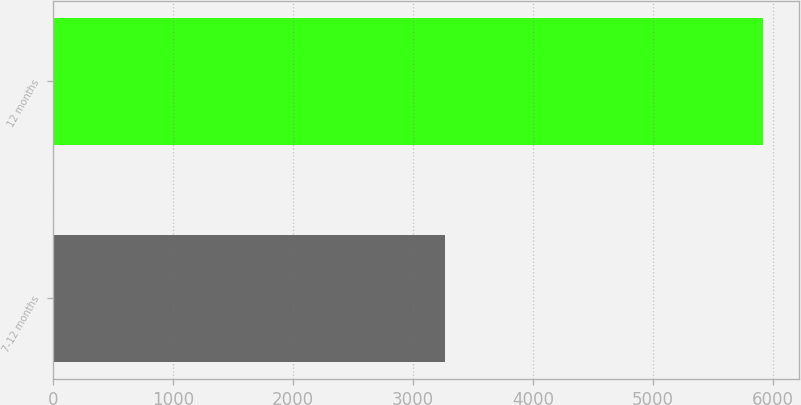<chart> <loc_0><loc_0><loc_500><loc_500><bar_chart><fcel>7-12 months<fcel>12 months<nl><fcel>3269<fcel>5920<nl></chart> 